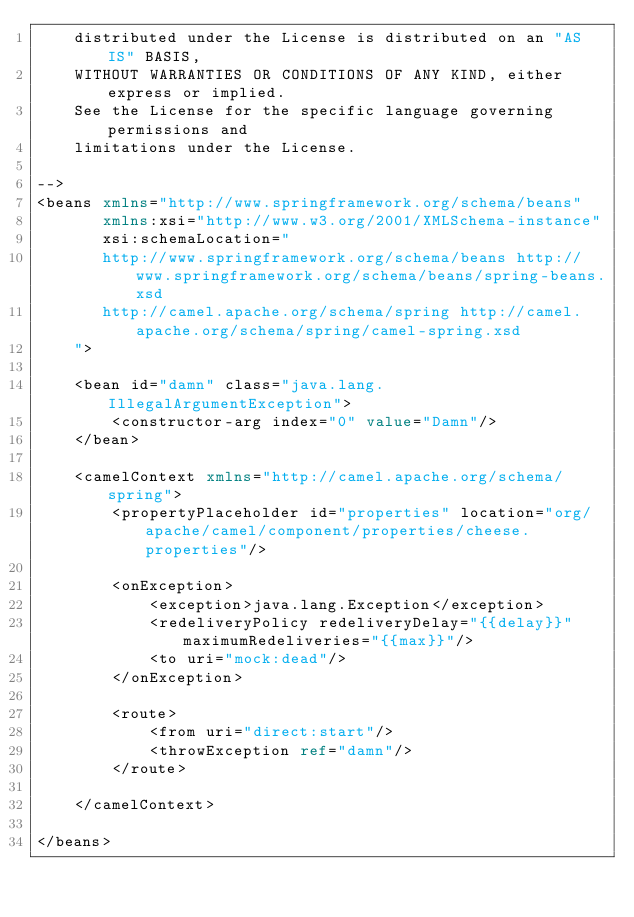<code> <loc_0><loc_0><loc_500><loc_500><_XML_>    distributed under the License is distributed on an "AS IS" BASIS,
    WITHOUT WARRANTIES OR CONDITIONS OF ANY KIND, either express or implied.
    See the License for the specific language governing permissions and
    limitations under the License.

-->
<beans xmlns="http://www.springframework.org/schema/beans"
       xmlns:xsi="http://www.w3.org/2001/XMLSchema-instance"
       xsi:schemaLocation="
       http://www.springframework.org/schema/beans http://www.springframework.org/schema/beans/spring-beans.xsd
       http://camel.apache.org/schema/spring http://camel.apache.org/schema/spring/camel-spring.xsd
    ">

    <bean id="damn" class="java.lang.IllegalArgumentException">
        <constructor-arg index="0" value="Damn"/>
    </bean>

    <camelContext xmlns="http://camel.apache.org/schema/spring">
        <propertyPlaceholder id="properties" location="org/apache/camel/component/properties/cheese.properties"/>

        <onException>
            <exception>java.lang.Exception</exception>
            <redeliveryPolicy redeliveryDelay="{{delay}}" maximumRedeliveries="{{max}}"/>
            <to uri="mock:dead"/>
        </onException>

        <route>
            <from uri="direct:start"/>
            <throwException ref="damn"/>
        </route>

    </camelContext>

</beans>
</code> 